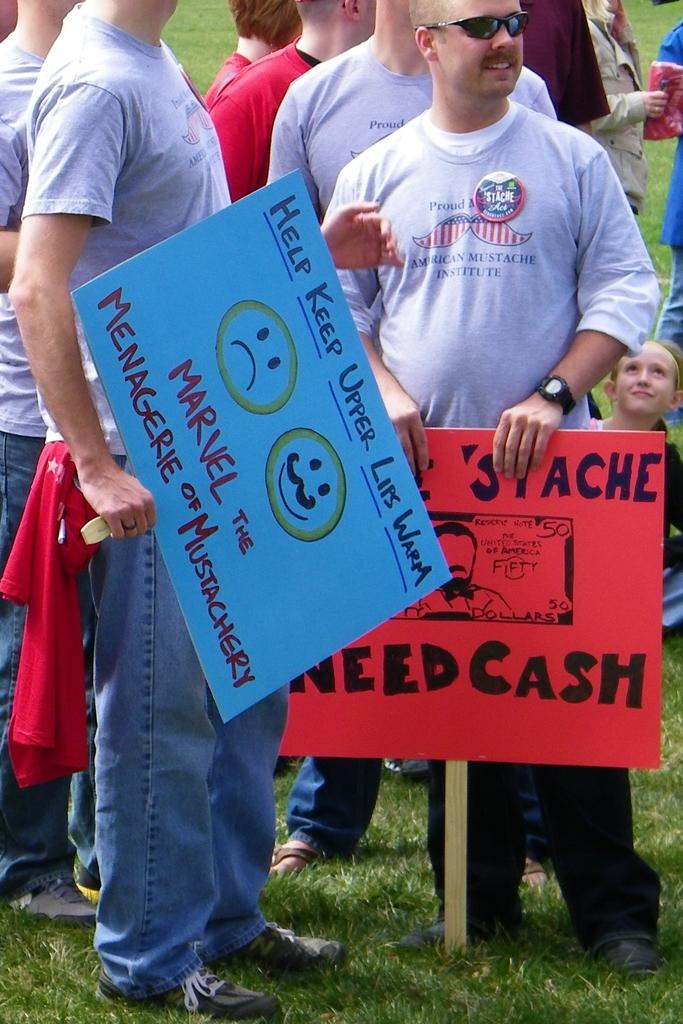What are the people in the image doing? The people in the image are standing on the ground. What are the people holding in their hands? The people are holding placards in their hands. Can you describe the woman in the background? There is a woman sitting on the ground in the background. What type of bun is the woman eating in the image? There is no bun present in the image; the woman is sitting on the ground. How much sugar is visible in the image? There is no sugar visible in the image. 